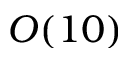Convert formula to latex. <formula><loc_0><loc_0><loc_500><loc_500>O ( 1 0 )</formula> 